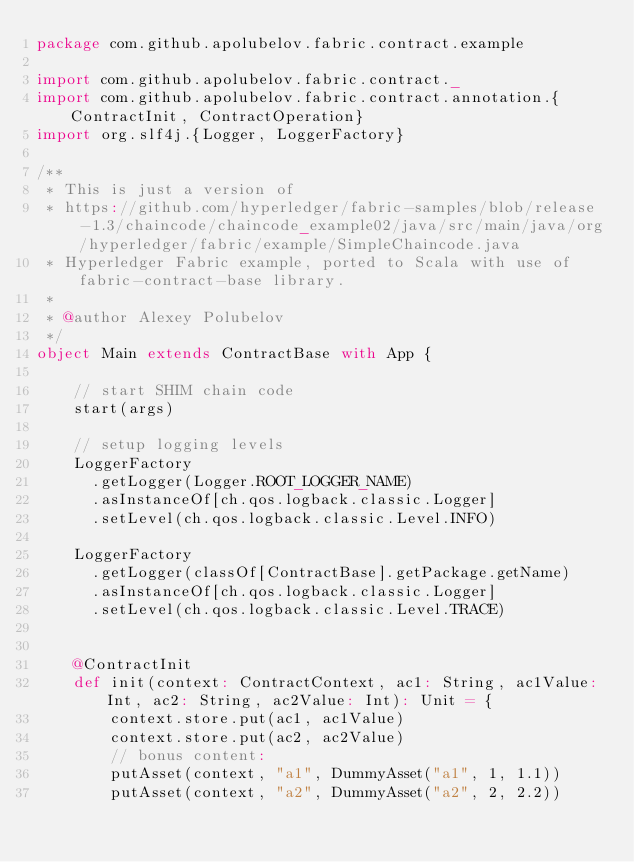<code> <loc_0><loc_0><loc_500><loc_500><_Scala_>package com.github.apolubelov.fabric.contract.example

import com.github.apolubelov.fabric.contract._
import com.github.apolubelov.fabric.contract.annotation.{ContractInit, ContractOperation}
import org.slf4j.{Logger, LoggerFactory}

/**
 * This is just a version of
 * https://github.com/hyperledger/fabric-samples/blob/release-1.3/chaincode/chaincode_example02/java/src/main/java/org/hyperledger/fabric/example/SimpleChaincode.java
 * Hyperledger Fabric example, ported to Scala with use of fabric-contract-base library.
 *
 * @author Alexey Polubelov
 */
object Main extends ContractBase with App {

    // start SHIM chain code
    start(args)

    // setup logging levels
    LoggerFactory
      .getLogger(Logger.ROOT_LOGGER_NAME)
      .asInstanceOf[ch.qos.logback.classic.Logger]
      .setLevel(ch.qos.logback.classic.Level.INFO)

    LoggerFactory
      .getLogger(classOf[ContractBase].getPackage.getName)
      .asInstanceOf[ch.qos.logback.classic.Logger]
      .setLevel(ch.qos.logback.classic.Level.TRACE)


    @ContractInit
    def init(context: ContractContext, ac1: String, ac1Value: Int, ac2: String, ac2Value: Int): Unit = {
        context.store.put(ac1, ac1Value)
        context.store.put(ac2, ac2Value)
        // bonus content:
        putAsset(context, "a1", DummyAsset("a1", 1, 1.1))
        putAsset(context, "a2", DummyAsset("a2", 2, 2.2))</code> 